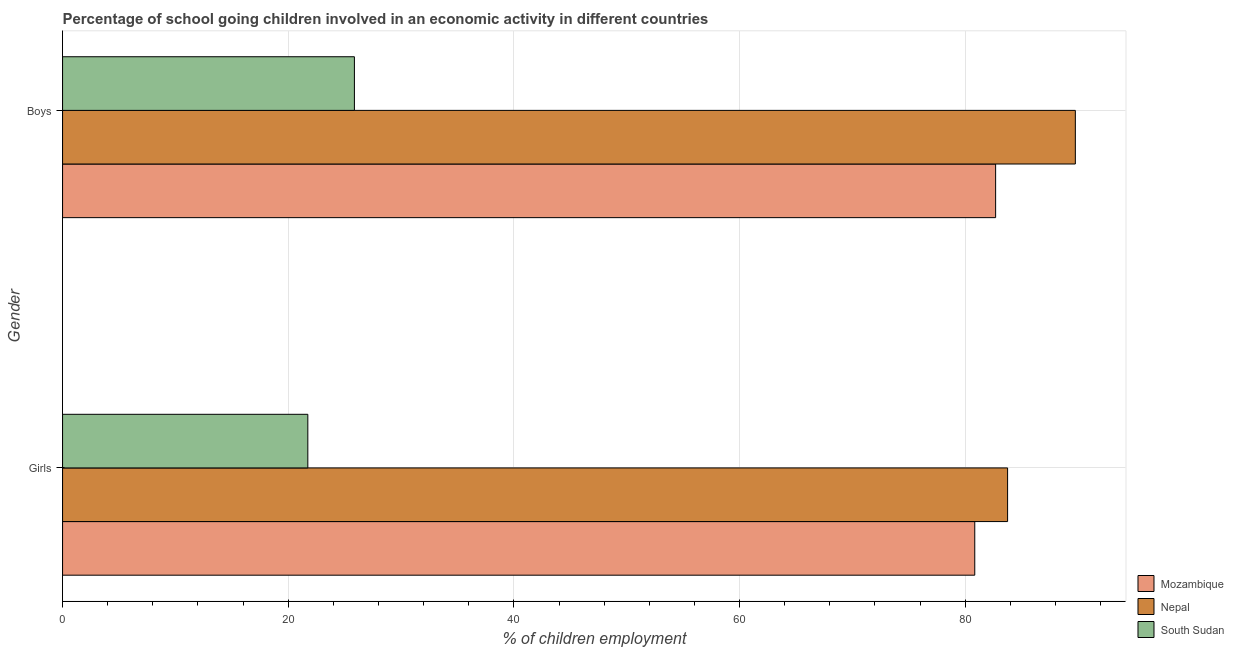How many different coloured bars are there?
Give a very brief answer. 3. How many bars are there on the 2nd tick from the top?
Ensure brevity in your answer.  3. What is the label of the 2nd group of bars from the top?
Your answer should be very brief. Girls. What is the percentage of school going girls in South Sudan?
Offer a very short reply. 21.74. Across all countries, what is the maximum percentage of school going boys?
Provide a succinct answer. 89.76. Across all countries, what is the minimum percentage of school going girls?
Your answer should be compact. 21.74. In which country was the percentage of school going girls maximum?
Your response must be concise. Nepal. In which country was the percentage of school going boys minimum?
Your response must be concise. South Sudan. What is the total percentage of school going girls in the graph?
Ensure brevity in your answer.  186.35. What is the difference between the percentage of school going girls in Nepal and that in South Sudan?
Make the answer very short. 62.02. What is the difference between the percentage of school going boys in Nepal and the percentage of school going girls in Mozambique?
Offer a very short reply. 8.91. What is the average percentage of school going girls per country?
Make the answer very short. 62.12. What is the difference between the percentage of school going boys and percentage of school going girls in Mozambique?
Your answer should be compact. 1.85. In how many countries, is the percentage of school going boys greater than 56 %?
Provide a short and direct response. 2. What is the ratio of the percentage of school going girls in Nepal to that in Mozambique?
Your response must be concise. 1.04. Is the percentage of school going girls in Mozambique less than that in South Sudan?
Ensure brevity in your answer.  No. What does the 3rd bar from the top in Boys represents?
Provide a short and direct response. Mozambique. What does the 2nd bar from the bottom in Boys represents?
Provide a succinct answer. Nepal. How many bars are there?
Offer a very short reply. 6. How many countries are there in the graph?
Ensure brevity in your answer.  3. Are the values on the major ticks of X-axis written in scientific E-notation?
Offer a very short reply. No. Does the graph contain grids?
Offer a terse response. Yes. How many legend labels are there?
Provide a short and direct response. 3. How are the legend labels stacked?
Keep it short and to the point. Vertical. What is the title of the graph?
Your response must be concise. Percentage of school going children involved in an economic activity in different countries. Does "West Bank and Gaza" appear as one of the legend labels in the graph?
Make the answer very short. No. What is the label or title of the X-axis?
Provide a short and direct response. % of children employment. What is the % of children employment in Mozambique in Girls?
Ensure brevity in your answer.  80.85. What is the % of children employment of Nepal in Girls?
Keep it short and to the point. 83.76. What is the % of children employment in South Sudan in Girls?
Make the answer very short. 21.74. What is the % of children employment of Mozambique in Boys?
Your answer should be very brief. 82.7. What is the % of children employment of Nepal in Boys?
Your response must be concise. 89.76. What is the % of children employment in South Sudan in Boys?
Give a very brief answer. 25.87. Across all Gender, what is the maximum % of children employment of Mozambique?
Offer a very short reply. 82.7. Across all Gender, what is the maximum % of children employment of Nepal?
Your answer should be very brief. 89.76. Across all Gender, what is the maximum % of children employment in South Sudan?
Make the answer very short. 25.87. Across all Gender, what is the minimum % of children employment of Mozambique?
Offer a very short reply. 80.85. Across all Gender, what is the minimum % of children employment in Nepal?
Provide a short and direct response. 83.76. Across all Gender, what is the minimum % of children employment in South Sudan?
Keep it short and to the point. 21.74. What is the total % of children employment in Mozambique in the graph?
Ensure brevity in your answer.  163.55. What is the total % of children employment in Nepal in the graph?
Offer a terse response. 173.52. What is the total % of children employment of South Sudan in the graph?
Your response must be concise. 47.6. What is the difference between the % of children employment of Mozambique in Girls and that in Boys?
Offer a terse response. -1.85. What is the difference between the % of children employment of Nepal in Girls and that in Boys?
Provide a short and direct response. -6. What is the difference between the % of children employment in South Sudan in Girls and that in Boys?
Make the answer very short. -4.13. What is the difference between the % of children employment of Mozambique in Girls and the % of children employment of Nepal in Boys?
Provide a succinct answer. -8.91. What is the difference between the % of children employment of Mozambique in Girls and the % of children employment of South Sudan in Boys?
Offer a terse response. 54.98. What is the difference between the % of children employment of Nepal in Girls and the % of children employment of South Sudan in Boys?
Offer a terse response. 57.89. What is the average % of children employment of Mozambique per Gender?
Make the answer very short. 81.77. What is the average % of children employment of Nepal per Gender?
Ensure brevity in your answer.  86.76. What is the average % of children employment of South Sudan per Gender?
Ensure brevity in your answer.  23.8. What is the difference between the % of children employment of Mozambique and % of children employment of Nepal in Girls?
Provide a short and direct response. -2.91. What is the difference between the % of children employment in Mozambique and % of children employment in South Sudan in Girls?
Your response must be concise. 59.11. What is the difference between the % of children employment in Nepal and % of children employment in South Sudan in Girls?
Offer a very short reply. 62.02. What is the difference between the % of children employment in Mozambique and % of children employment in Nepal in Boys?
Ensure brevity in your answer.  -7.07. What is the difference between the % of children employment in Mozambique and % of children employment in South Sudan in Boys?
Offer a terse response. 56.83. What is the difference between the % of children employment in Nepal and % of children employment in South Sudan in Boys?
Make the answer very short. 63.9. What is the ratio of the % of children employment of Mozambique in Girls to that in Boys?
Give a very brief answer. 0.98. What is the ratio of the % of children employment in Nepal in Girls to that in Boys?
Make the answer very short. 0.93. What is the ratio of the % of children employment in South Sudan in Girls to that in Boys?
Offer a terse response. 0.84. What is the difference between the highest and the second highest % of children employment of Mozambique?
Provide a short and direct response. 1.85. What is the difference between the highest and the second highest % of children employment of Nepal?
Offer a terse response. 6. What is the difference between the highest and the second highest % of children employment of South Sudan?
Provide a short and direct response. 4.13. What is the difference between the highest and the lowest % of children employment in Mozambique?
Provide a short and direct response. 1.85. What is the difference between the highest and the lowest % of children employment of Nepal?
Your response must be concise. 6. What is the difference between the highest and the lowest % of children employment of South Sudan?
Provide a short and direct response. 4.13. 